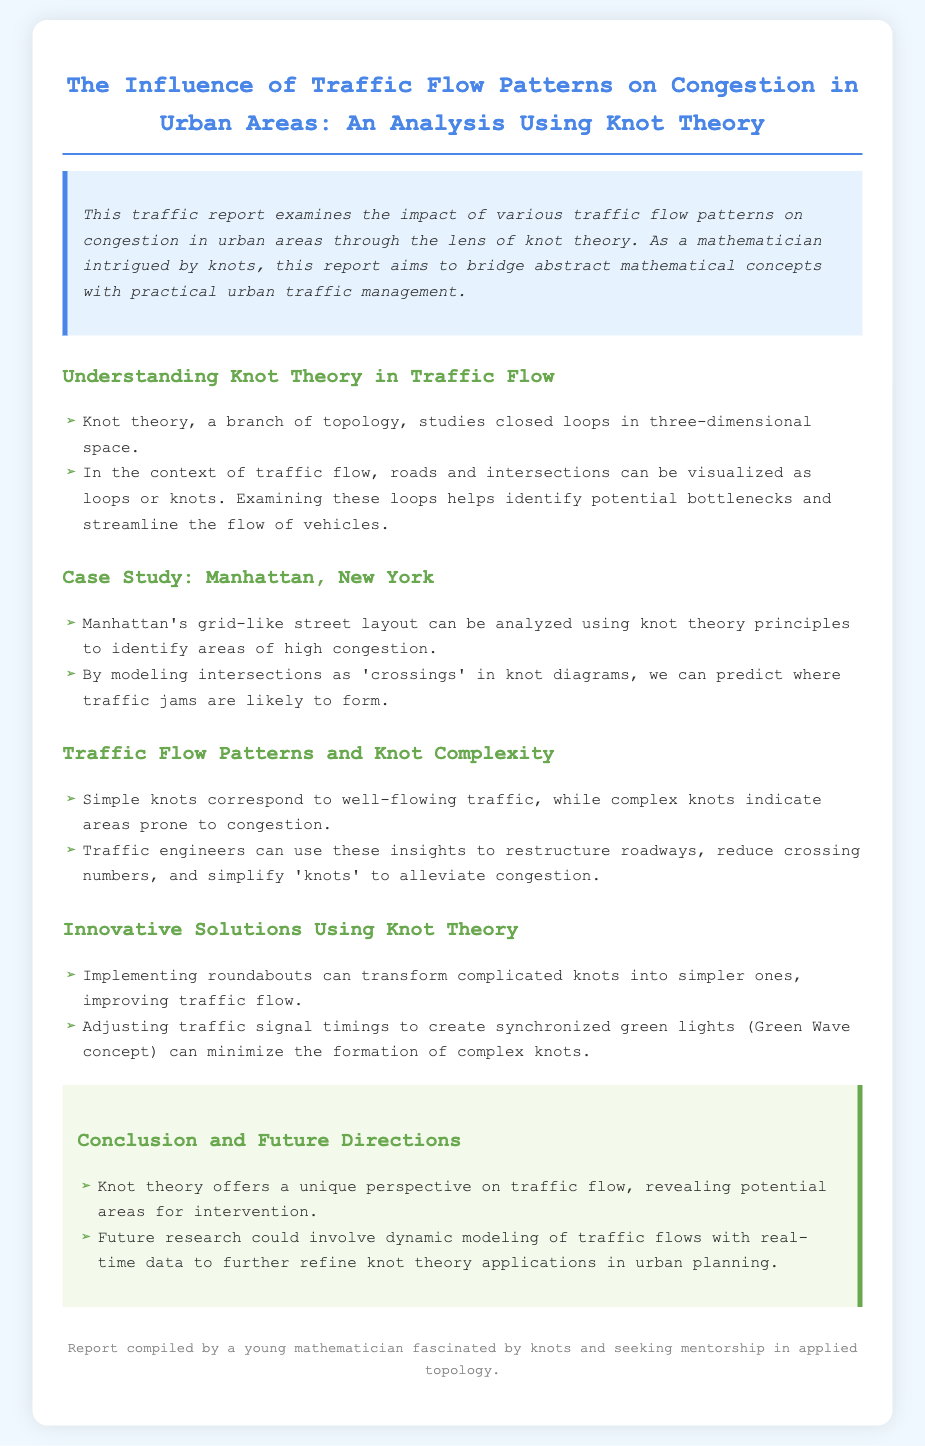what is the focus of the traffic report? The report focuses on the impact of traffic flow patterns on congestion in urban areas through the lens of knot theory.
Answer: traffic flow patterns and congestion what concept from mathematics is applied in this report? The report applies knot theory, which studies closed loops in three-dimensional space, to analyze traffic flow.
Answer: knot theory which urban area's traffic flow is analyzed as a case study? The report analyzes traffic flow in Manhattan, New York, using knot theory principles.
Answer: Manhattan, New York how do simple knots relate to traffic conditions? Simple knots correspond to well-flowing traffic, indicating less congestion.
Answer: well-flowing traffic what is one innovative solution suggested in the report? One solution suggested is implementing roundabouts to transform complicated knots into simpler ones.
Answer: roundabouts what does the Green Wave concept refer to? The Green Wave concept refers to adjusting traffic signal timings to create synchronized green lights.
Answer: synchronized green lights what potential future direction does the report suggest? The report suggests future research could involve dynamic modeling of traffic flows with real-time data.
Answer: dynamic modeling of traffic flows how are intersections modeled in the analysis? Intersections are modeled as 'crossings' in knot diagrams to predict traffic jams.
Answer: 'crossings' in knot diagrams what type of report is this document classified as? The document is classified as a traffic report, analyzing urban traffic management through mathematical concepts.
Answer: traffic report 